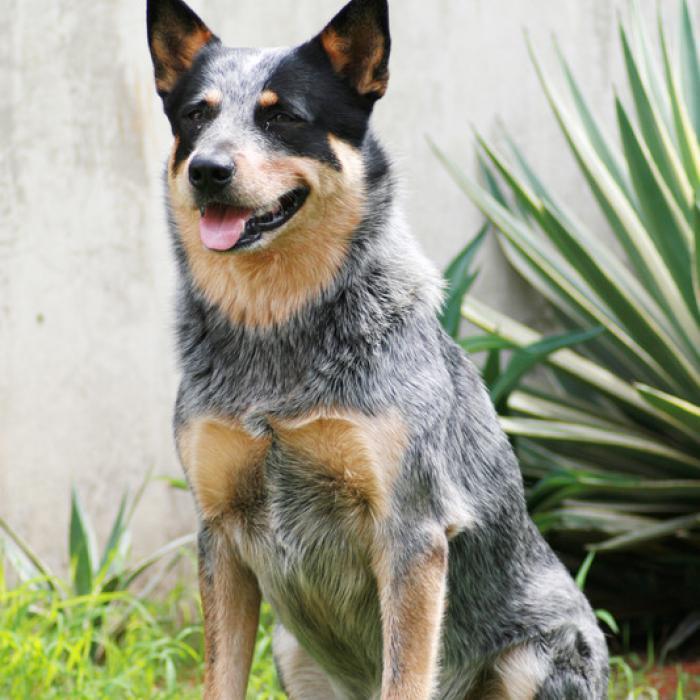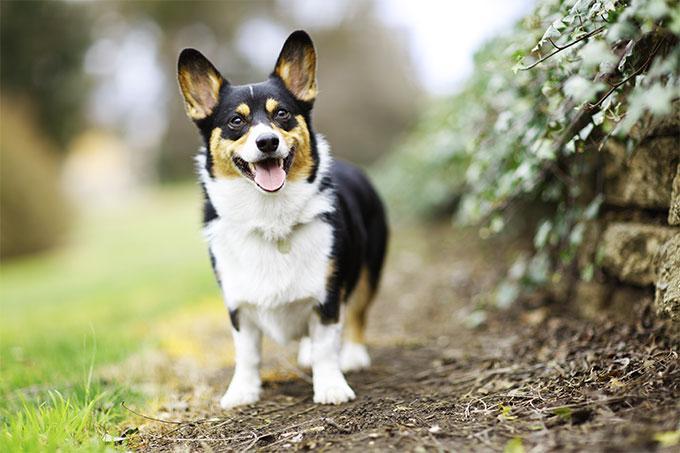The first image is the image on the left, the second image is the image on the right. Evaluate the accuracy of this statement regarding the images: "One image contains twice as many dogs as the other image.". Is it true? Answer yes or no. No. The first image is the image on the left, the second image is the image on the right. For the images displayed, is the sentence "At least one dog is sitting in the grass." factually correct? Answer yes or no. Yes. 